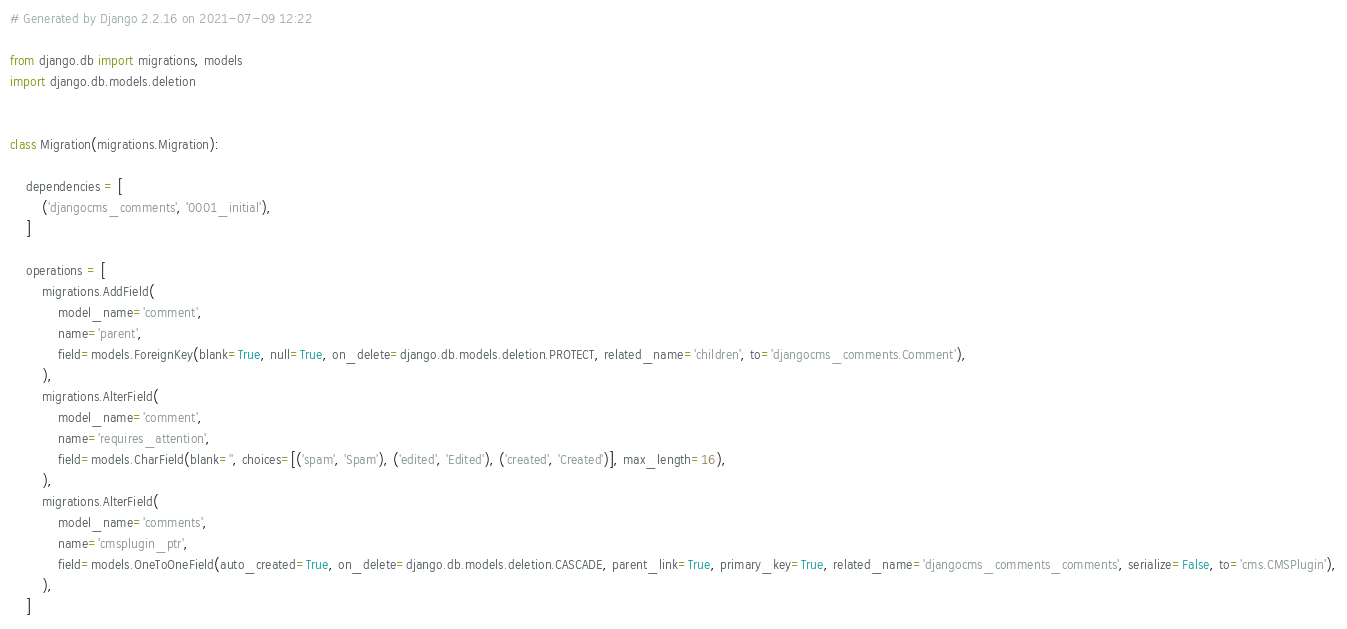Convert code to text. <code><loc_0><loc_0><loc_500><loc_500><_Python_># Generated by Django 2.2.16 on 2021-07-09 12:22

from django.db import migrations, models
import django.db.models.deletion


class Migration(migrations.Migration):

    dependencies = [
        ('djangocms_comments', '0001_initial'),
    ]

    operations = [
        migrations.AddField(
            model_name='comment',
            name='parent',
            field=models.ForeignKey(blank=True, null=True, on_delete=django.db.models.deletion.PROTECT, related_name='children', to='djangocms_comments.Comment'),
        ),
        migrations.AlterField(
            model_name='comment',
            name='requires_attention',
            field=models.CharField(blank='', choices=[('spam', 'Spam'), ('edited', 'Edited'), ('created', 'Created')], max_length=16),
        ),
        migrations.AlterField(
            model_name='comments',
            name='cmsplugin_ptr',
            field=models.OneToOneField(auto_created=True, on_delete=django.db.models.deletion.CASCADE, parent_link=True, primary_key=True, related_name='djangocms_comments_comments', serialize=False, to='cms.CMSPlugin'),
        ),
    ]
</code> 